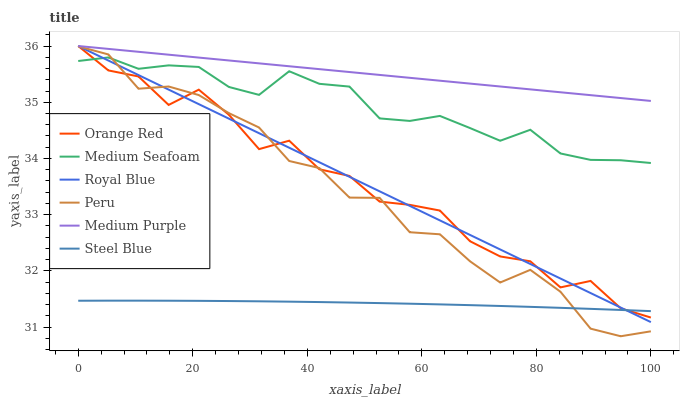Does Medium Seafoam have the minimum area under the curve?
Answer yes or no. No. Does Medium Seafoam have the maximum area under the curve?
Answer yes or no. No. Is Medium Seafoam the smoothest?
Answer yes or no. No. Is Medium Seafoam the roughest?
Answer yes or no. No. Does Medium Seafoam have the lowest value?
Answer yes or no. No. Does Medium Seafoam have the highest value?
Answer yes or no. No. Is Peru less than Medium Purple?
Answer yes or no. Yes. Is Medium Purple greater than Peru?
Answer yes or no. Yes. Does Peru intersect Medium Purple?
Answer yes or no. No. 